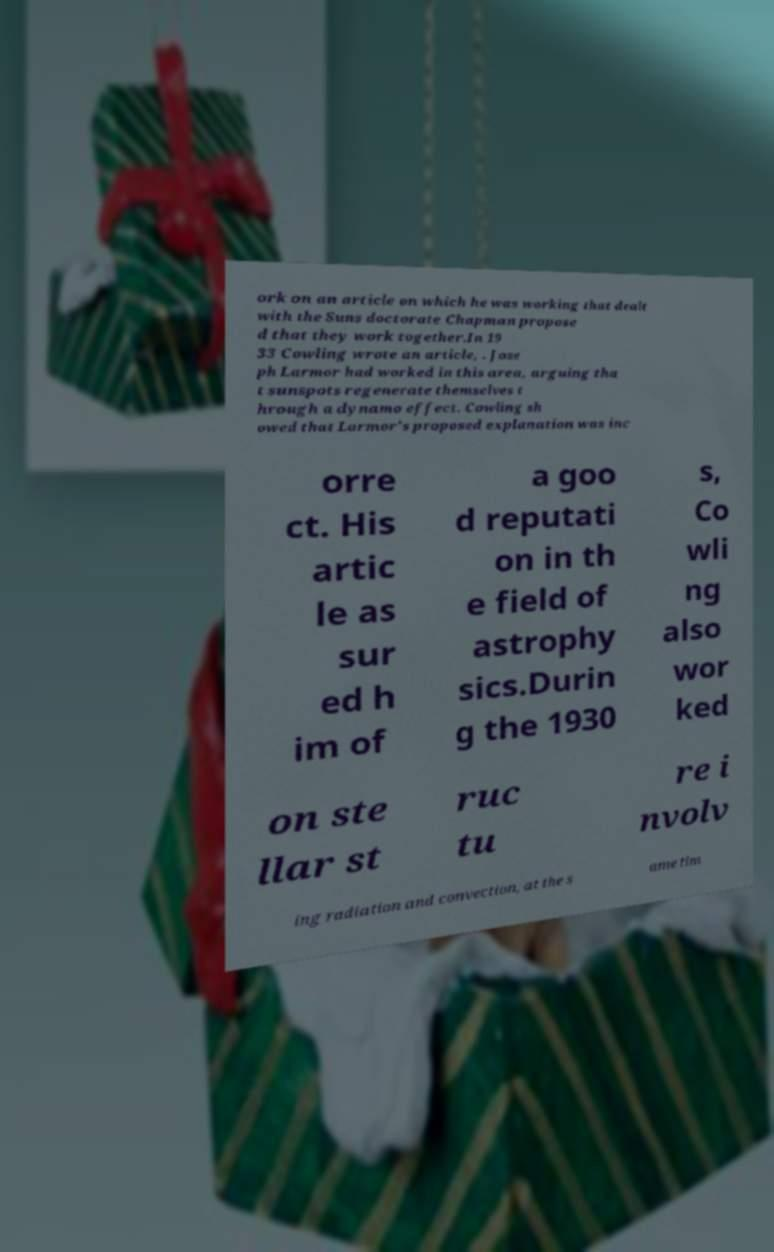Could you extract and type out the text from this image? ork on an article on which he was working that dealt with the Suns doctorate Chapman propose d that they work together.In 19 33 Cowling wrote an article, . Jose ph Larmor had worked in this area, arguing tha t sunspots regenerate themselves t hrough a dynamo effect. Cowling sh owed that Larmor's proposed explanation was inc orre ct. His artic le as sur ed h im of a goo d reputati on in th e field of astrophy sics.Durin g the 1930 s, Co wli ng also wor ked on ste llar st ruc tu re i nvolv ing radiation and convection, at the s ame tim 